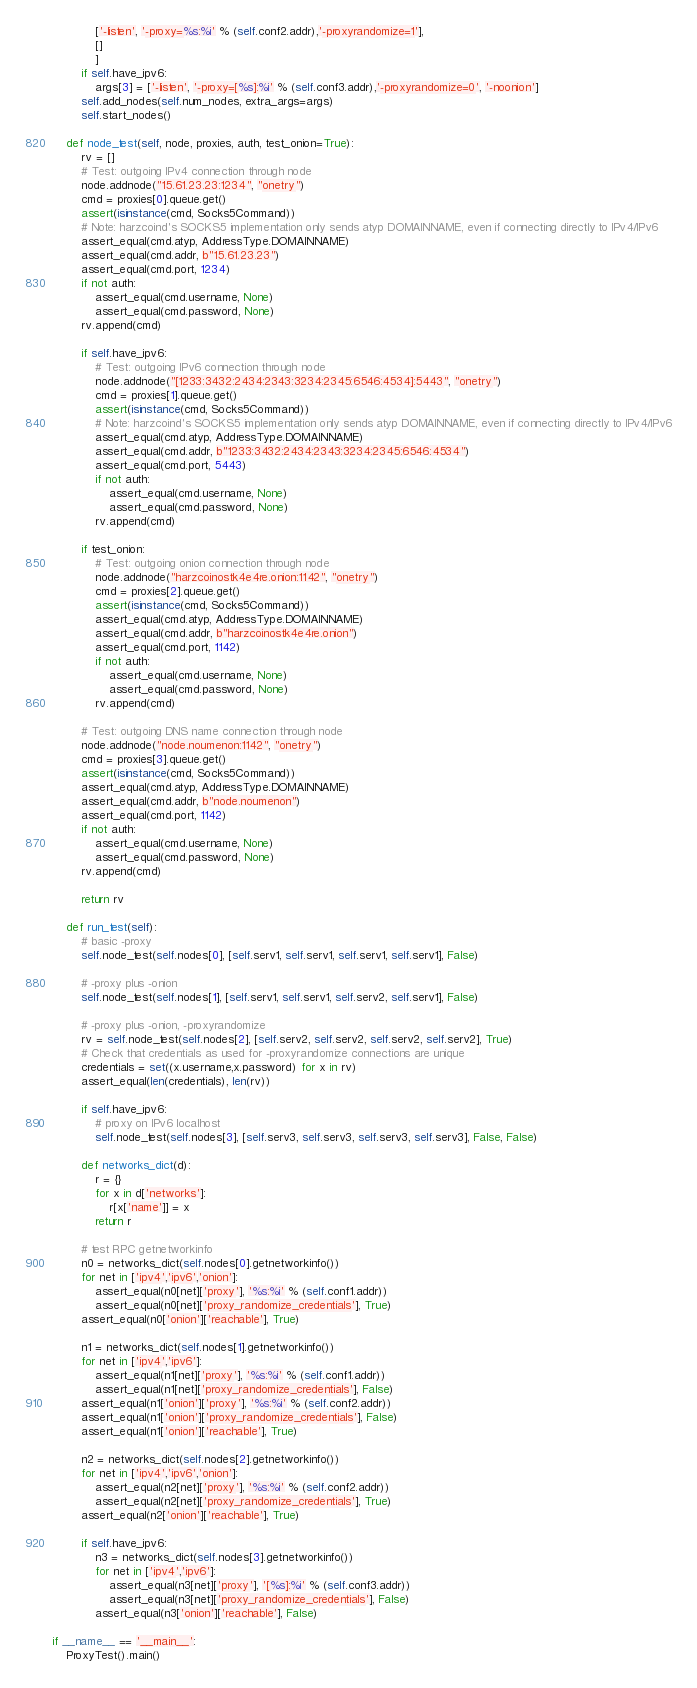<code> <loc_0><loc_0><loc_500><loc_500><_Python_>            ['-listen', '-proxy=%s:%i' % (self.conf2.addr),'-proxyrandomize=1'], 
            []
            ]
        if self.have_ipv6:
            args[3] = ['-listen', '-proxy=[%s]:%i' % (self.conf3.addr),'-proxyrandomize=0', '-noonion']
        self.add_nodes(self.num_nodes, extra_args=args)
        self.start_nodes()

    def node_test(self, node, proxies, auth, test_onion=True):
        rv = []
        # Test: outgoing IPv4 connection through node
        node.addnode("15.61.23.23:1234", "onetry")
        cmd = proxies[0].queue.get()
        assert(isinstance(cmd, Socks5Command))
        # Note: harzcoind's SOCKS5 implementation only sends atyp DOMAINNAME, even if connecting directly to IPv4/IPv6
        assert_equal(cmd.atyp, AddressType.DOMAINNAME)
        assert_equal(cmd.addr, b"15.61.23.23")
        assert_equal(cmd.port, 1234)
        if not auth:
            assert_equal(cmd.username, None)
            assert_equal(cmd.password, None)
        rv.append(cmd)

        if self.have_ipv6:
            # Test: outgoing IPv6 connection through node
            node.addnode("[1233:3432:2434:2343:3234:2345:6546:4534]:5443", "onetry")
            cmd = proxies[1].queue.get()
            assert(isinstance(cmd, Socks5Command))
            # Note: harzcoind's SOCKS5 implementation only sends atyp DOMAINNAME, even if connecting directly to IPv4/IPv6
            assert_equal(cmd.atyp, AddressType.DOMAINNAME)
            assert_equal(cmd.addr, b"1233:3432:2434:2343:3234:2345:6546:4534")
            assert_equal(cmd.port, 5443)
            if not auth:
                assert_equal(cmd.username, None)
                assert_equal(cmd.password, None)
            rv.append(cmd)

        if test_onion:
            # Test: outgoing onion connection through node
            node.addnode("harzcoinostk4e4re.onion:1142", "onetry")
            cmd = proxies[2].queue.get()
            assert(isinstance(cmd, Socks5Command))
            assert_equal(cmd.atyp, AddressType.DOMAINNAME)
            assert_equal(cmd.addr, b"harzcoinostk4e4re.onion")
            assert_equal(cmd.port, 1142)
            if not auth:
                assert_equal(cmd.username, None)
                assert_equal(cmd.password, None)
            rv.append(cmd)

        # Test: outgoing DNS name connection through node
        node.addnode("node.noumenon:1142", "onetry")
        cmd = proxies[3].queue.get()
        assert(isinstance(cmd, Socks5Command))
        assert_equal(cmd.atyp, AddressType.DOMAINNAME)
        assert_equal(cmd.addr, b"node.noumenon")
        assert_equal(cmd.port, 1142)
        if not auth:
            assert_equal(cmd.username, None)
            assert_equal(cmd.password, None)
        rv.append(cmd)

        return rv

    def run_test(self):
        # basic -proxy
        self.node_test(self.nodes[0], [self.serv1, self.serv1, self.serv1, self.serv1], False)

        # -proxy plus -onion
        self.node_test(self.nodes[1], [self.serv1, self.serv1, self.serv2, self.serv1], False)

        # -proxy plus -onion, -proxyrandomize
        rv = self.node_test(self.nodes[2], [self.serv2, self.serv2, self.serv2, self.serv2], True)
        # Check that credentials as used for -proxyrandomize connections are unique
        credentials = set((x.username,x.password) for x in rv)
        assert_equal(len(credentials), len(rv))

        if self.have_ipv6:
            # proxy on IPv6 localhost
            self.node_test(self.nodes[3], [self.serv3, self.serv3, self.serv3, self.serv3], False, False)

        def networks_dict(d):
            r = {}
            for x in d['networks']:
                r[x['name']] = x
            return r

        # test RPC getnetworkinfo
        n0 = networks_dict(self.nodes[0].getnetworkinfo())
        for net in ['ipv4','ipv6','onion']:
            assert_equal(n0[net]['proxy'], '%s:%i' % (self.conf1.addr))
            assert_equal(n0[net]['proxy_randomize_credentials'], True)
        assert_equal(n0['onion']['reachable'], True)

        n1 = networks_dict(self.nodes[1].getnetworkinfo())
        for net in ['ipv4','ipv6']:
            assert_equal(n1[net]['proxy'], '%s:%i' % (self.conf1.addr))
            assert_equal(n1[net]['proxy_randomize_credentials'], False)
        assert_equal(n1['onion']['proxy'], '%s:%i' % (self.conf2.addr))
        assert_equal(n1['onion']['proxy_randomize_credentials'], False)
        assert_equal(n1['onion']['reachable'], True)
        
        n2 = networks_dict(self.nodes[2].getnetworkinfo())
        for net in ['ipv4','ipv6','onion']:
            assert_equal(n2[net]['proxy'], '%s:%i' % (self.conf2.addr))
            assert_equal(n2[net]['proxy_randomize_credentials'], True)
        assert_equal(n2['onion']['reachable'], True)

        if self.have_ipv6:
            n3 = networks_dict(self.nodes[3].getnetworkinfo())
            for net in ['ipv4','ipv6']:
                assert_equal(n3[net]['proxy'], '[%s]:%i' % (self.conf3.addr))
                assert_equal(n3[net]['proxy_randomize_credentials'], False)
            assert_equal(n3['onion']['reachable'], False)

if __name__ == '__main__':
    ProxyTest().main()

</code> 